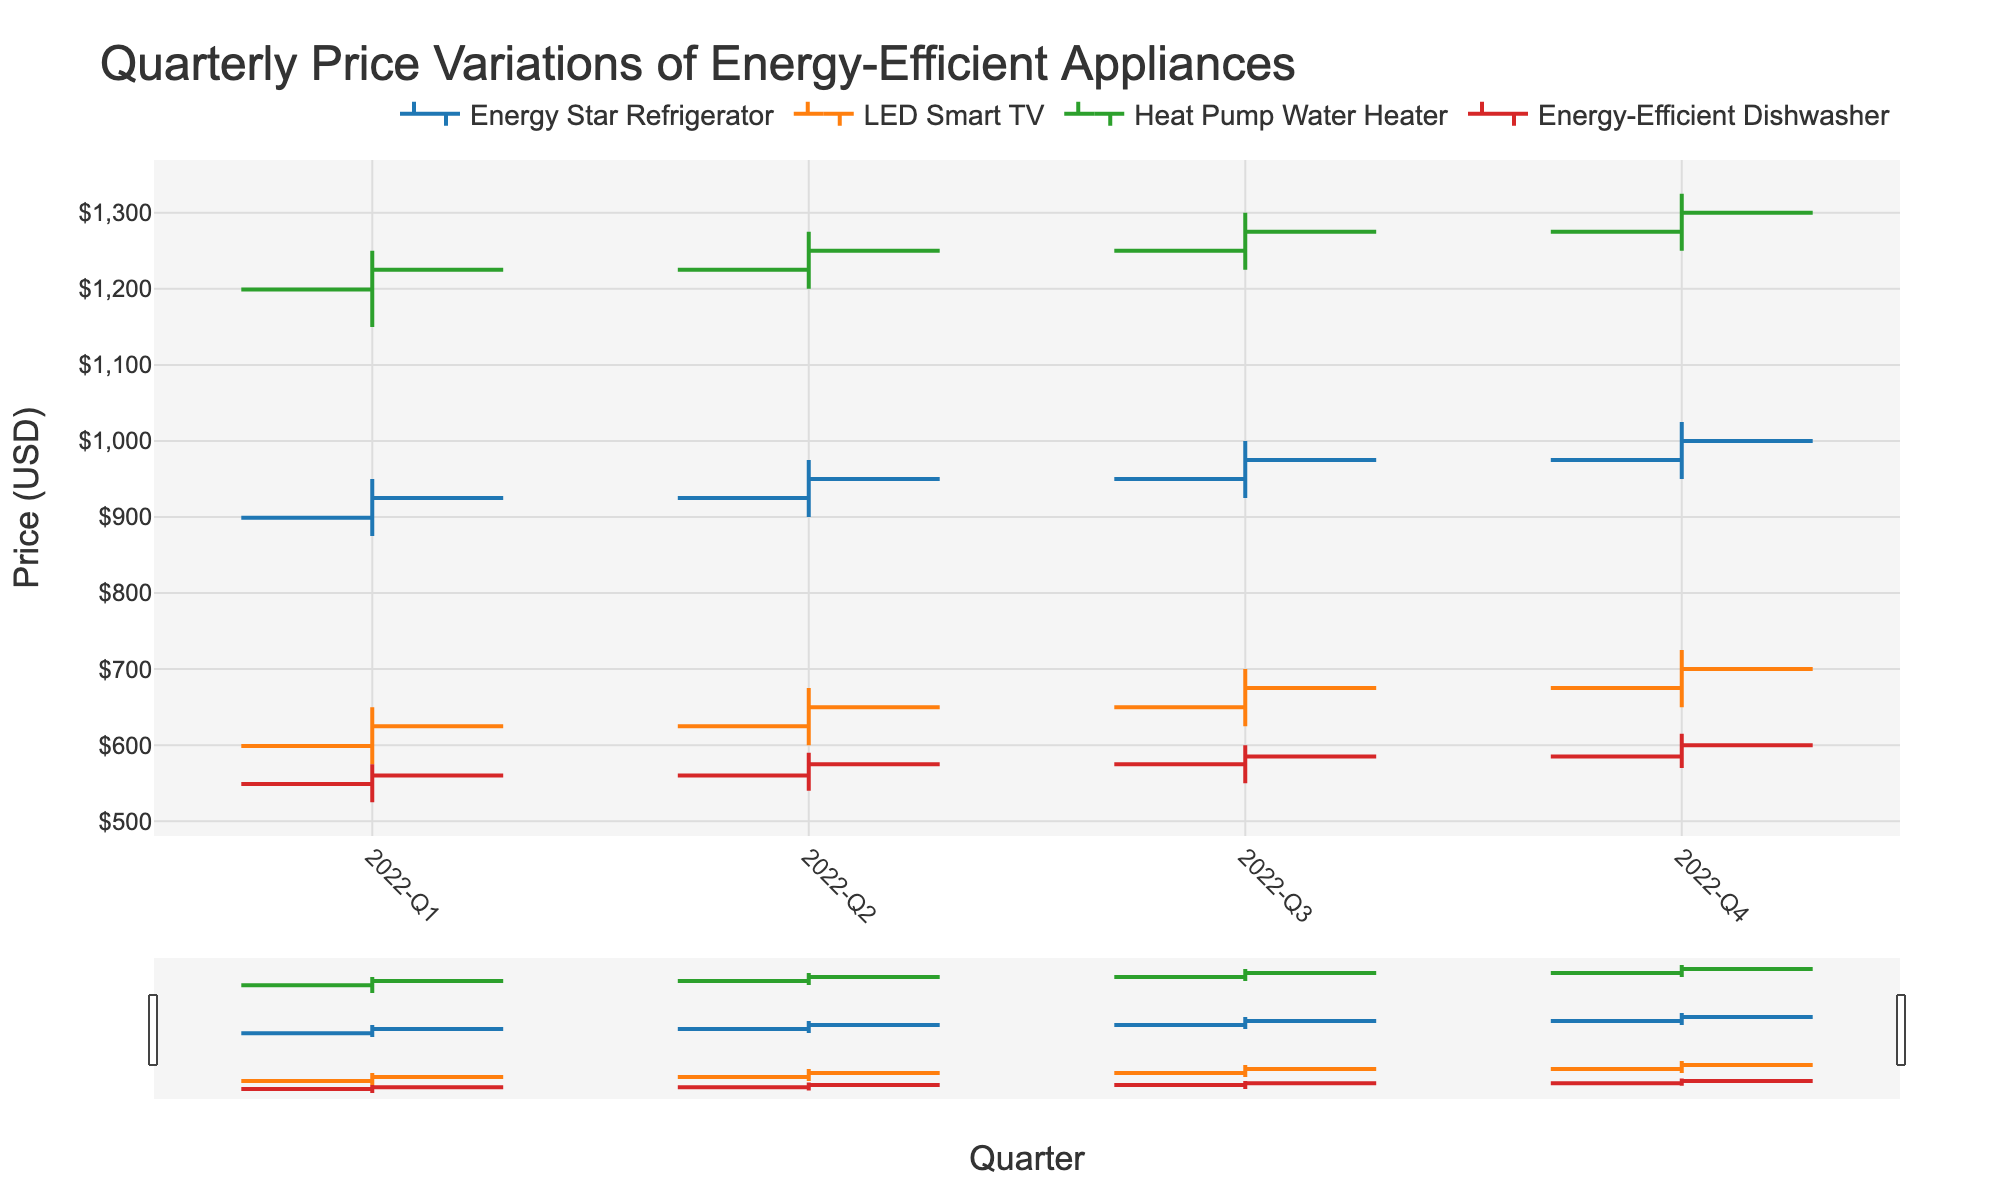what is the title of the chart? The title of the chart is typically displayed prominently at the top of the figure. By looking at the figure, one can see that the title reads "Quarterly Price Variations of Energy-Efficient Appliances"
Answer: Quarterly Price Variations of Energy-Efficient Appliances Which appliance had the highest price in Q4 2022? To find the highest price in Q4 2022, look at the highest point in the OHLC chart for each appliance in Q4. The Heat Pump Water Heater reached a high price of $1325, which is the highest among the appliances.
Answer: Heat Pump Water Heater How much did the closing price of the Energy Star Refrigerator increase from Q1 2022 to Q4 2022? To find the increase, subtract the closing price in Q1 2022 from the closing price in Q4 2022. The closing price in Q1 2022 is $925, and in Q4 2022, it is $1000. Therefore, the increase is $1000 - $925 = $75.
Answer: $75 Which quarter saw the highest price for the Energy-Efficient Dishwasher? Locate the high prices for the Energy-Efficient Dishwasher in each quarter within the chart. The highest price was $615 in Q4 2022.
Answer: Q4 2022 What is the average of the closing prices for the LED Smart TV across all quarters? Calculate the average by summing up the closing prices in all quarters and dividing by the number of quarters. The closing prices are $625, $650, $675, and $700. The sum is $2650, and the number of quarters is 4. Therefore, the average is $2650 / 4 = $662.50.
Answer: $662.50 Which appliance experienced the greatest increase in closing price from Q1 to Q4 of 2022? Determine the difference between the Q1 and Q4 closing prices for each appliance and compare them. The differences are: Energy Star Refrigerator ($1000-$925=$75), LED Smart TV ($700-$625=$75), Heat Pump Water Heater ($1300-$1225=$75), and Energy-Efficient Dishwasher ($600-$560=$40). All except the Dishwasher increased by the same amount.
Answer: Energy Star Refrigerator, LED Smart TV, Heat Pump Water Heater How did the opening price of the Heat Pump Water Heater change from Q2 to Q3 in 2022? Compare the opening prices in Q2 and Q3 for the Heat Pump Water Heater. The opening price in Q2 is $1225, and in Q3, it is $1250. The change is $1250 - $1225 = $25.
Answer: Increased by $25 In which quarter did the LED Smart TV experience the smallest range in prices? The range is calculated as the difference between the high and low prices for each quarter. For LED Smart TV, the ranges are: Q1 ($75), Q2 ($75), Q3 ($75), and Q4 ($75). Since all are the same, it doesn't experience a smallest range in any quarter.
Answer: None (all quarters have the same range) What trend can be observed in the prices of the Energy Star Refrigerator throughout 2022? Observing the OHLC chart for the Energy Star Refrigerator shows that both the opening and closing prices increase steadily each quarter from Q1 to Q4.
Answer: Increasing trend Which appliance had the lowest low price in Q2 2022, and what was that price? Find the lowest low prices for each appliance in Q2 2022. The lowest lows are: Energy Star Refrigerator ($900), LED Smart TV ($600), Heat Pump Water Heater ($1200), and Energy-Efficient Dishwasher ($540). The lowest low price among them is $540 for the Energy-Efficient Dishwasher.
Answer: Energy-Efficient Dishwasher, $540 